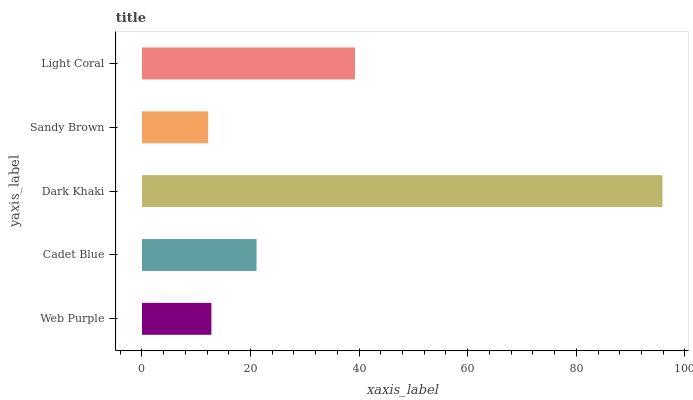Is Sandy Brown the minimum?
Answer yes or no. Yes. Is Dark Khaki the maximum?
Answer yes or no. Yes. Is Cadet Blue the minimum?
Answer yes or no. No. Is Cadet Blue the maximum?
Answer yes or no. No. Is Cadet Blue greater than Web Purple?
Answer yes or no. Yes. Is Web Purple less than Cadet Blue?
Answer yes or no. Yes. Is Web Purple greater than Cadet Blue?
Answer yes or no. No. Is Cadet Blue less than Web Purple?
Answer yes or no. No. Is Cadet Blue the high median?
Answer yes or no. Yes. Is Cadet Blue the low median?
Answer yes or no. Yes. Is Light Coral the high median?
Answer yes or no. No. Is Light Coral the low median?
Answer yes or no. No. 